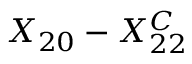<formula> <loc_0><loc_0><loc_500><loc_500>X _ { 2 0 } - X _ { 2 2 } ^ { C }</formula> 